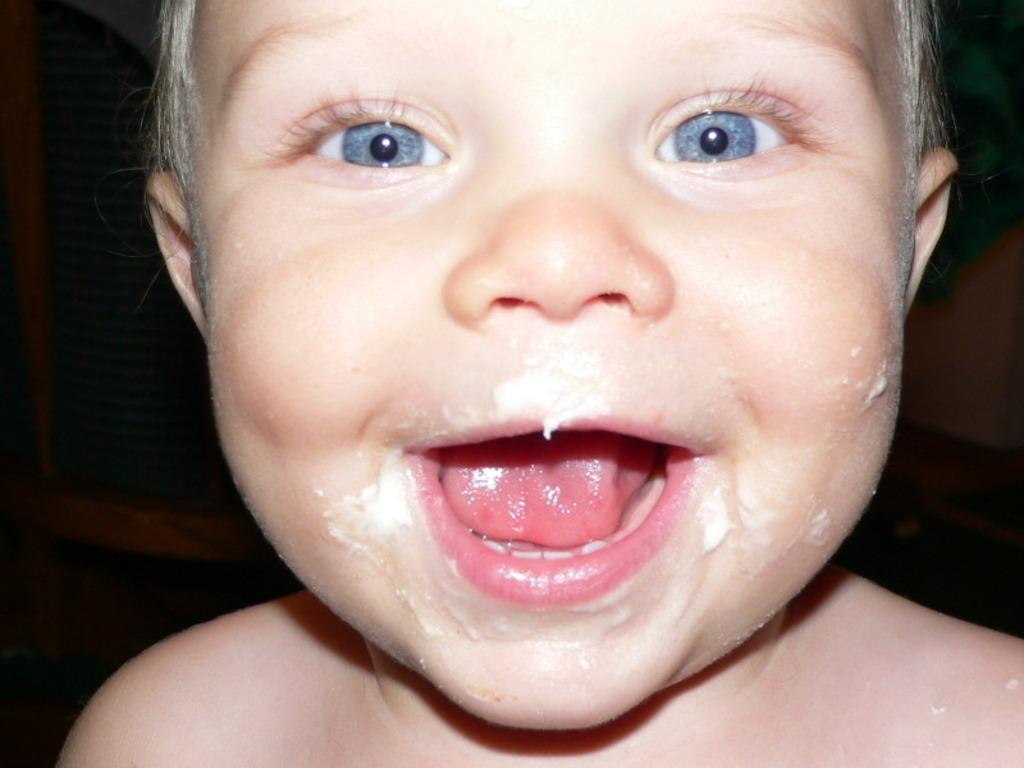Who is the main subject in the image? There is a little boy in the image. What is the little boy doing in the image? The little boy has opened his mouth in the image. Can you see the little boy swimming in the image? No, the little boy is not swimming in the image; he is standing with his mouth open. 